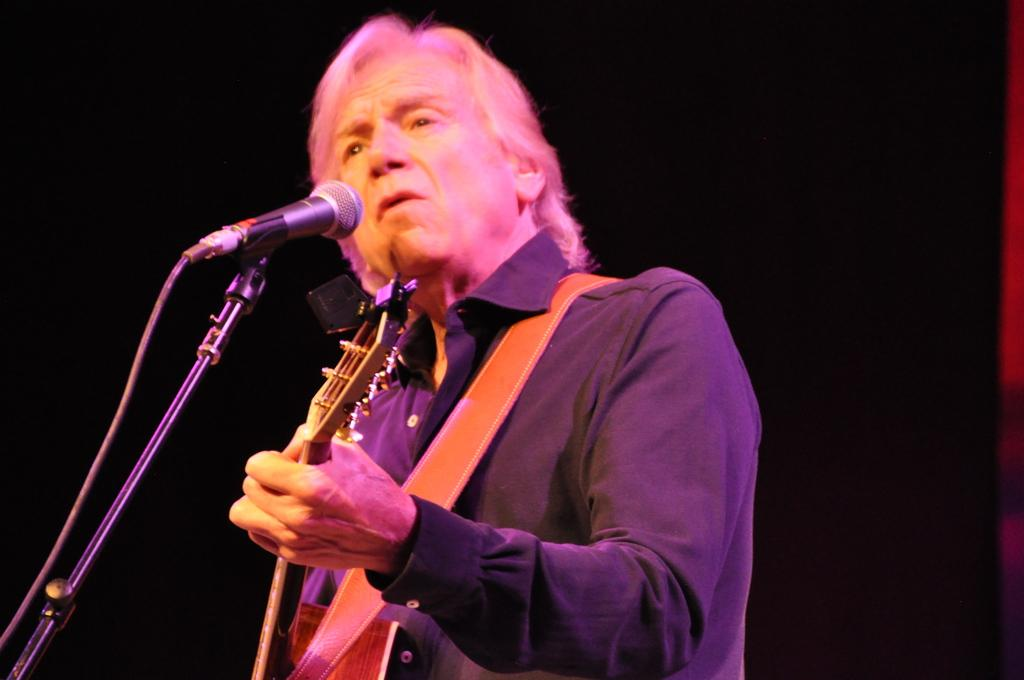What is the person in the image doing? The person is playing a guitar. What object is in front of the person? There is a microphone in front of the person. How would you describe the lighting in the image? The background of the image is dark. What type of science experiment is being conducted in the image? There is no science experiment present in the image; it features a person playing a guitar with a microphone in front of them. Can you see any flowers in the image? There are no flowers visible in the image. 